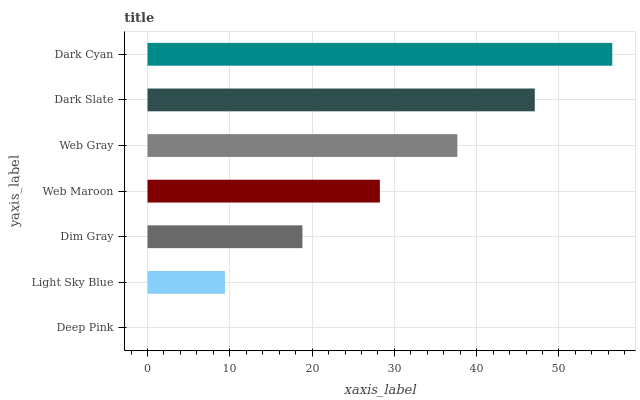Is Deep Pink the minimum?
Answer yes or no. Yes. Is Dark Cyan the maximum?
Answer yes or no. Yes. Is Light Sky Blue the minimum?
Answer yes or no. No. Is Light Sky Blue the maximum?
Answer yes or no. No. Is Light Sky Blue greater than Deep Pink?
Answer yes or no. Yes. Is Deep Pink less than Light Sky Blue?
Answer yes or no. Yes. Is Deep Pink greater than Light Sky Blue?
Answer yes or no. No. Is Light Sky Blue less than Deep Pink?
Answer yes or no. No. Is Web Maroon the high median?
Answer yes or no. Yes. Is Web Maroon the low median?
Answer yes or no. Yes. Is Light Sky Blue the high median?
Answer yes or no. No. Is Deep Pink the low median?
Answer yes or no. No. 